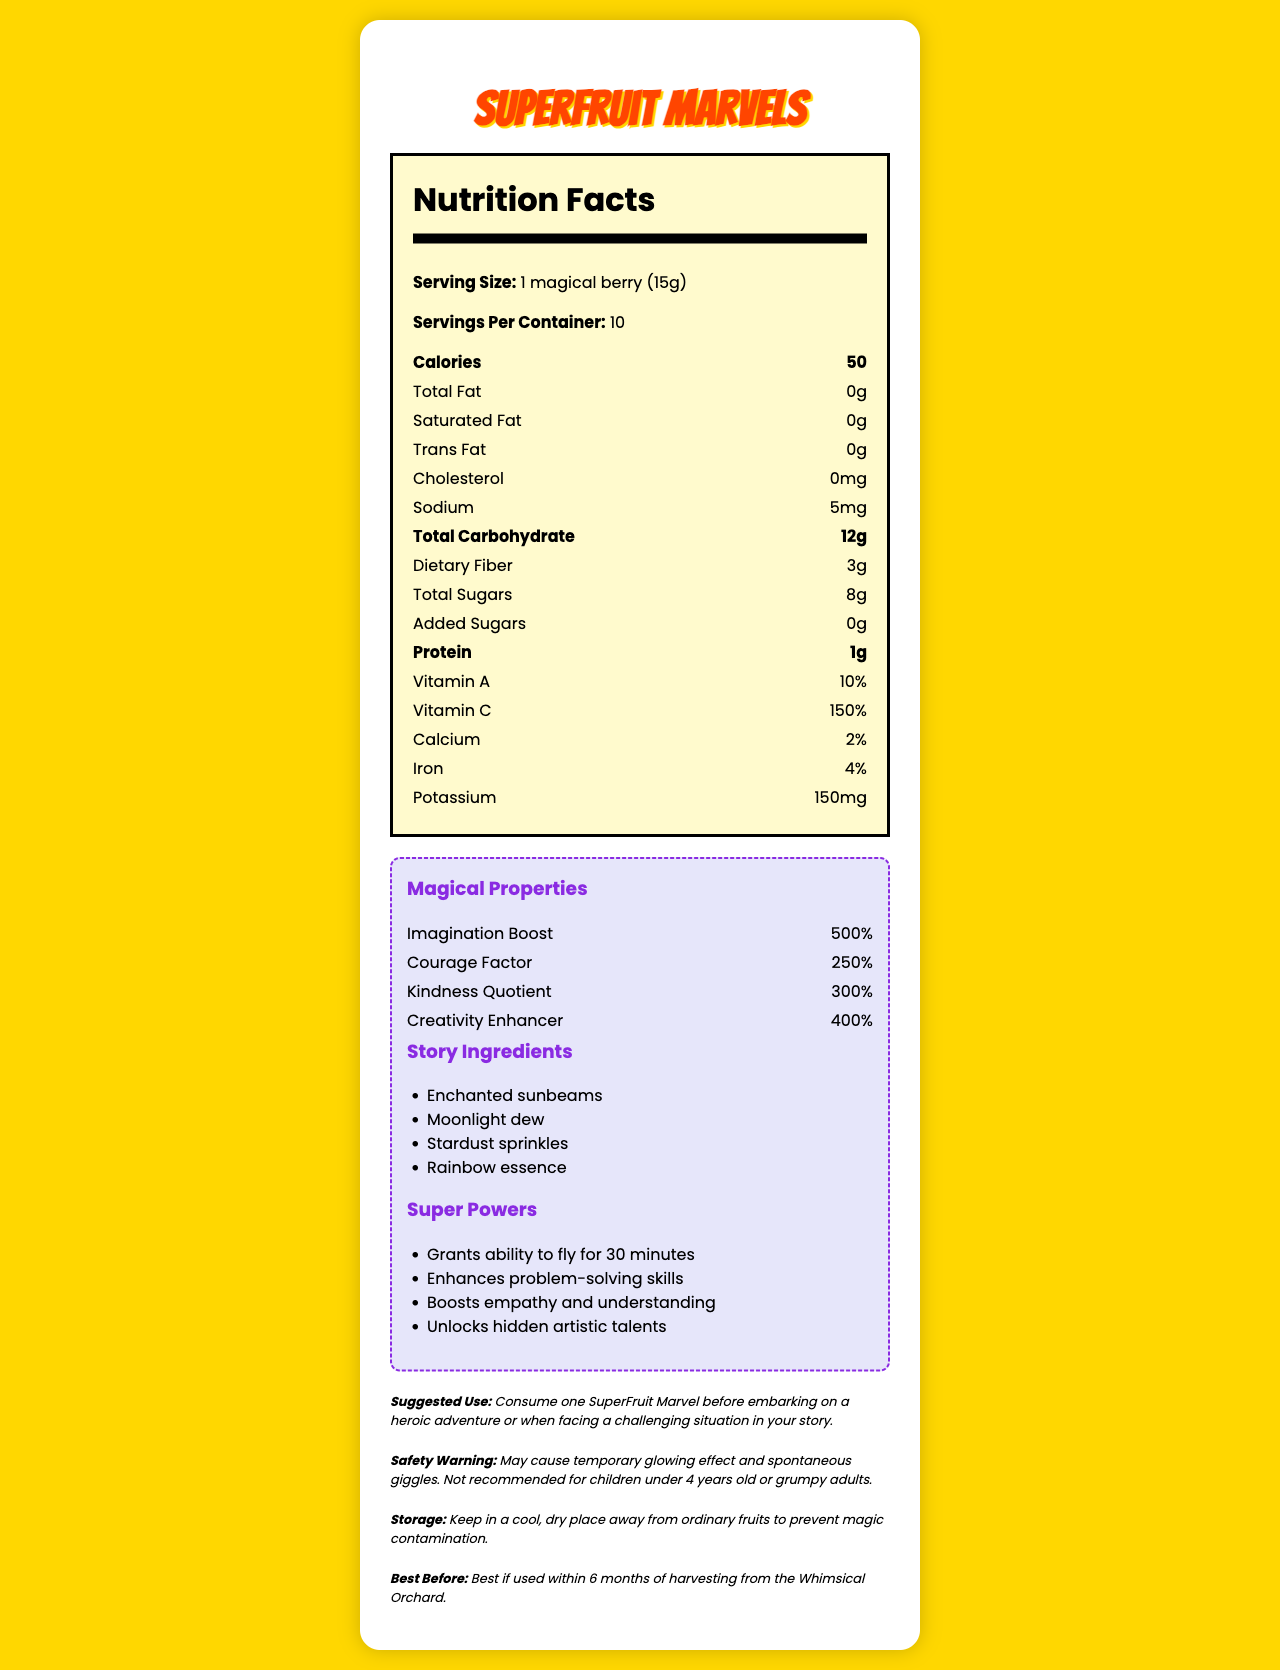what is the serving size? The serving size is clearly listed as "1 magical berry (15g)" under the Nutrition Facts section.
Answer: 1 magical berry (15g) how many servings are in one container of SuperFruit Marvels? The Nutrition Facts section specifies "Servings Per Container: 10."
Answer: 10 what is the calorie content per serving? The calories per serving are listed directly under the Nutrition Facts section and it states "Calories: 50."
Answer: 50 what is the sodium content per serving? The sodium content under the Nutrition Facts section is listed as "Sodium: 5mg."
Answer: 5mg which vitamin has the highest percentage daily value? Under the Nutrition Facts section, Vitamin C has a listed daily value of 150%, which is the highest compared to the other vitamins and minerals.
Answer: Vitamin C which magical property boosts imagination? A. Courage Factor B. Kindness Quotient C. Creativity Enhancer D. Imagination Boost The magical properties section lists "Imagination Boost: 500%" as a specific booster for imagination.
Answer: D what are the four story ingredients included in SuperFruit Marvels? These ingredients are listed under the "Story Ingredients" section.
Answer: Enchanted sunbeams, Moonlight dew, Stardust sprinkles, Rainbow essence which of the following is a suggested use for SuperFruit Marvels? A. Before bed B. With regular meals C. Before embarking on a heroic adventure D. As a dessert The suggested use is detailed as "Consume one SuperFruit Marvel before embarking on a heroic adventure or when facing a challenging situation in your story."
Answer: C does the SuperFruit Marvel contain any added sugars? The label clearly shows "Added Sugars: 0g."
Answer: No is it safe for children under 4 years old to consume SuperFruit Marvel? The safety warning mentions that it is "Not recommended for children under 4 years old."
Answer: No describe the main idea of this document The document combines a traditional nutrition label with imaginative elements, highlighting both health and magical benefits. It includes standard nutritional details and enchanting features such as boosts to imagination and courage, magical properties, and special ingredients, presenting an engaging mix for children.
Answer: The Nutrition Facts Label of SuperFruit Marvels includes standard nutritional information such as calories, fats, vitamins, and minerals, as well as unique magical properties, story ingredients, and suggested uses for children embarking on adventures. It provides both the nutritional benefits and the magical effects of consuming SuperFruit Marvels. where is the Whimsical Orchard located? The location of the Whimsical Orchard is not provided in the document. Only the expiration is mentioned as "Best if used within 6 months of harvesting from the Whimsical Orchard."
Answer: Cannot be determined 